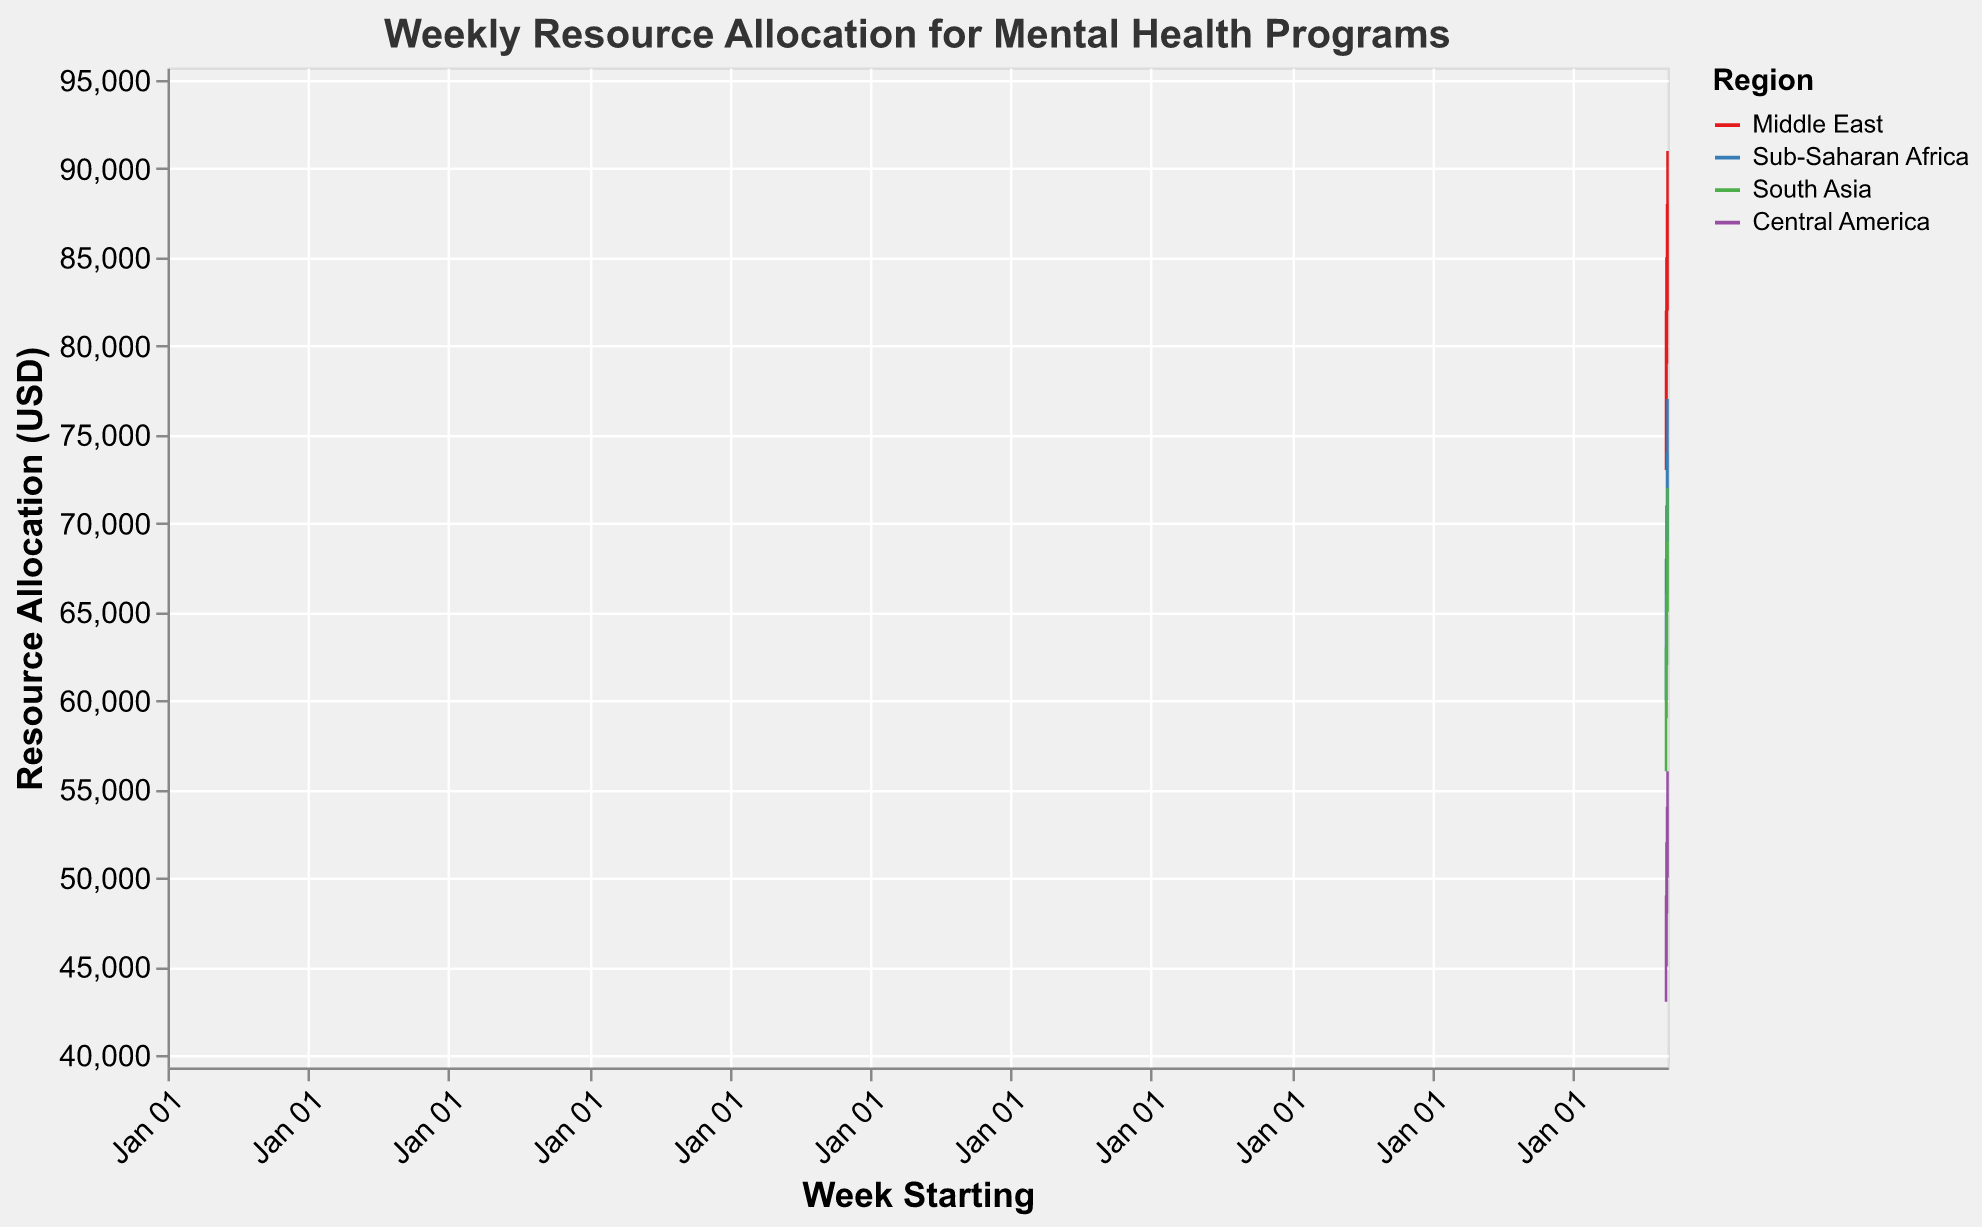What's the title of the chart? The title of the chart is clearly mentioned at the top and it reads "Weekly Resource Allocation for Mental Health Programs".
Answer: Weekly Resource Allocation for Mental Health Programs What regions are represented in the chart? By looking at the color legend in the chart, we can see that the regions represented are "Middle East", "Sub-Saharan Africa", "South Asia", and "Central America".
Answer: Middle East, Sub-Saharan Africa, South Asia, Central America What was the highest resource allocation in the Middle East during May 2023? Referring to the highest "High" value for the Middle East across all the data points in May 2023, it is 91,000 USD on May 22, 2023.
Answer: 91,000 USD Which region had the lowest resource allocation on the week starting May 1, 2023? We need to look at the "Low" values for each region on May 1, 2023, and identify the lowest among them. Central America had the lowest value of 43,000 USD.
Answer: Central America How did the resource allocation change in Sub-Saharan Africa from May 8 to May 15, 2023? Comparing the "Close" value on May 8 (69,000 USD) to the "Close" value on May 15 (72,000 USD), we see an increase of 3,000 USD.
Answer: Increased by 3,000 USD What is the average "Close" value for South Asia over the given weeks? Add the "Close" values for South Asia for all given weeks (61,000 + 64,000 + 67,000 + 70,000) and divide by 4, resulting in (61,000 + 64,000 + 67,000 + 70,000) / 4 = 65,500 USD.
Answer: 65,500 USD Which region showed the most consistent weekly resource allocation trend? Comparing the ranges (High-Low) and the week-to-week changes in allocation across all regions, South Asia shows the most consistent trends with relatively small week-to-week changes and small ranges.
Answer: South Asia How does the trend for Central America compare to that of the Middle East over May 2023? The Middle East shows a consistent increasing trend with rising "High" and "Close" values each week, while Central America also showed rising "High" and "Close" values but at a smaller scale and more stable.
Answer: Middle East shows consistent growth; Central America is more stable What was the opening resource allocation for Sub-Saharan Africa on May 22, 2023? Refer to the "Open" value for Sub-Saharan Africa on May 22, 2023, which is 72,000 USD.
Answer: 72,000 USD 